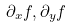Convert formula to latex. <formula><loc_0><loc_0><loc_500><loc_500>\partial _ { x } f , \partial _ { y } f</formula> 